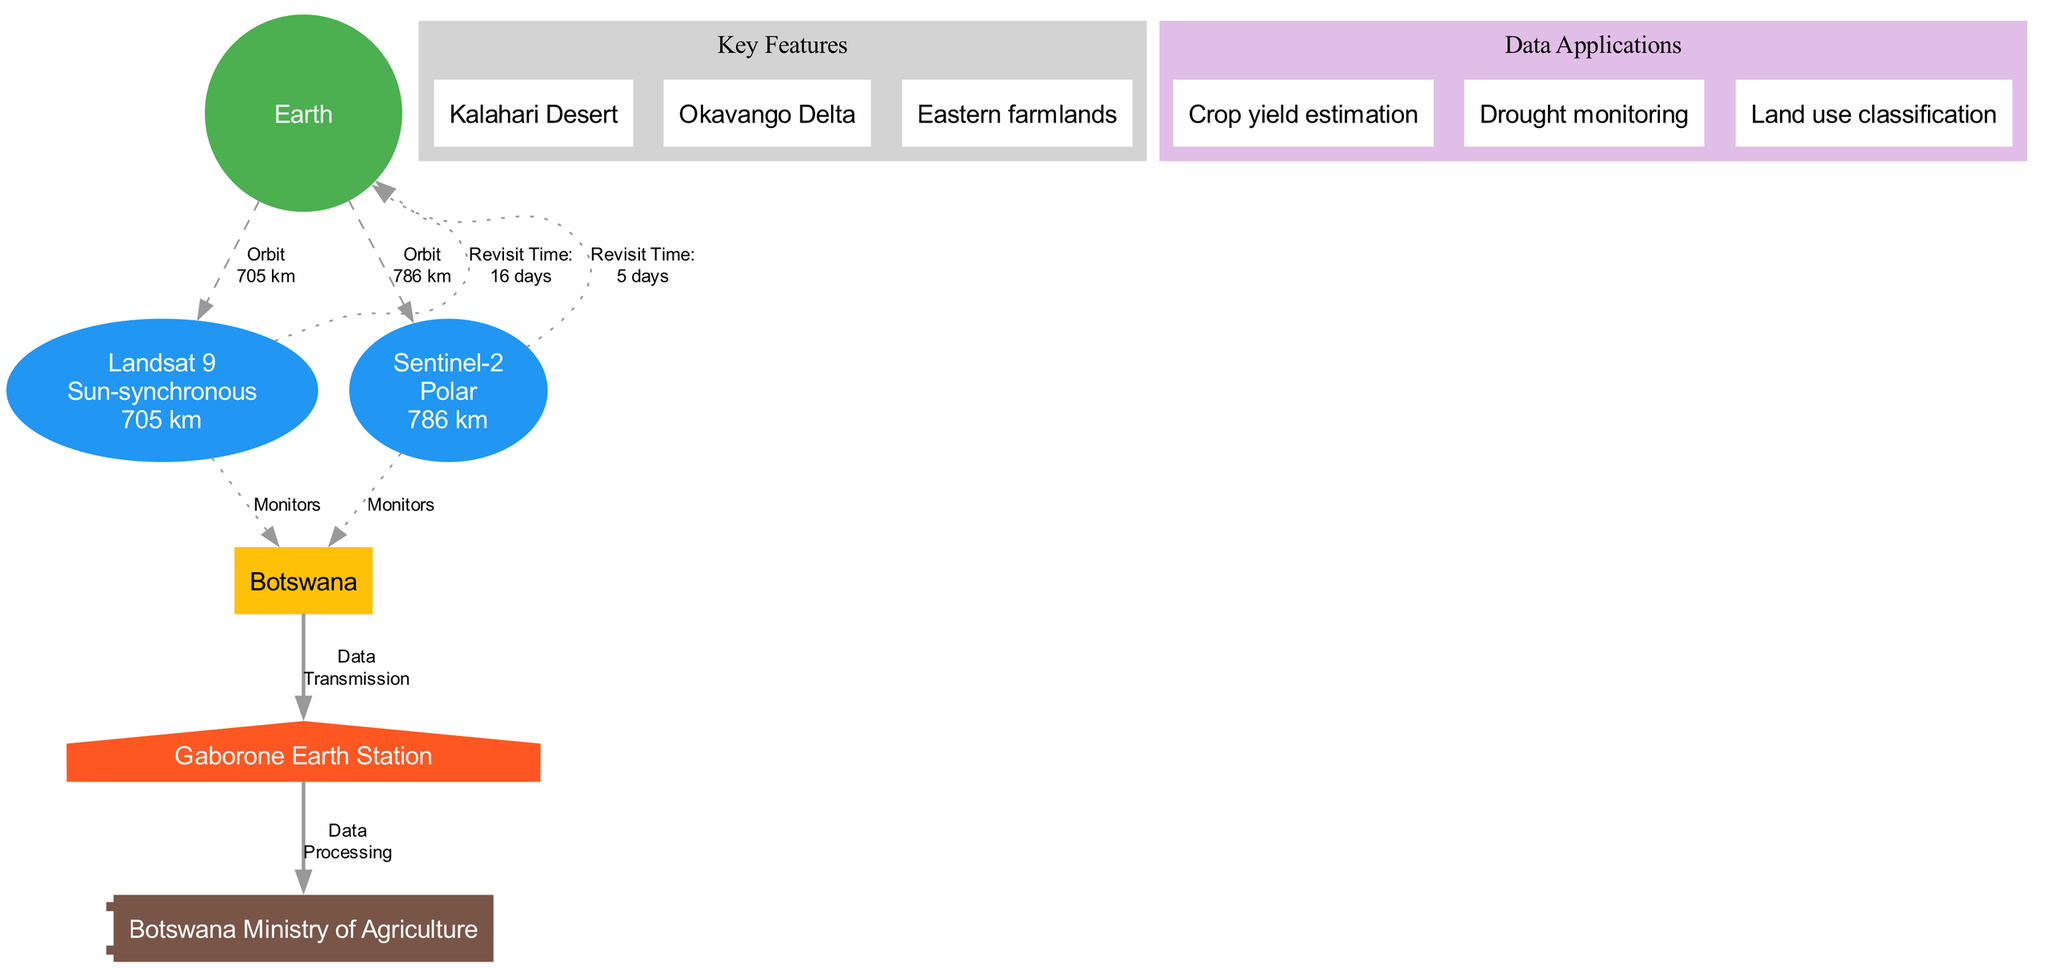What is the altitude of Landsat 9? The altitude for Landsat 9 is explicitly mentioned in the diagram, indicating it is 705 km above the Earth.
Answer: 705 km What is the revisit time for Sentinel-2? The revisit time for Sentinel-2 is shown in the diagram and is given as 5 days, meaning it passes over the same point on Earth every 5 days.
Answer: 5 days Which key feature is located in Botswana? The diagram lists three key features for Botswana, including the Kalahari Desert, Okavango Delta, and Eastern farmlands. One of these is the Kalahari Desert, identified as a significant geographical feature in Botswana.
Answer: Kalahari Desert How many satellites are used for agricultural monitoring in the diagram? The diagram specifically shows two satellites, Landsat 9 and Sentinel-2, which are dedicated to agricultural monitoring over Botswana.
Answer: 2 What is the data application related to drought? Among the listed data applications in the diagram, one directly relates to drought monitoring, indicating how satellite data is utilized in tracking drought conditions in Botswana.
Answer: Drought monitoring What type of orbit does Landsat 9 have? The orbit type for Landsat 9 is labeled in the diagram as sun-synchronous, which means the satellite maintains a constant position relative to the sun, crucial for consistent imaging conditions.
Answer: Sun-synchronous What is the relationship between the coverage area and the ground station? The diagram depicts the ground station in Gaborone as connected to the coverage area of Botswana through a bold edge labeled 'Data Transmission,' indicating that data from the satellites is sent to this ground station for processing.
Answer: Data Transmission What is the color of the Earth node in the diagram? In the diagram, the Earth node is vividly colored green (#4CAF50), which is explicitly specified to visually differentiate it as the central body of the diagram.
Answer: Green What type of orbit does Sentinel-2 have? The orbit type for Sentinel-2, as indicated in the diagram, is polar, which means it follows a path that takes it over the poles, allowing it to cover a broad swath of the Earth's surface including Botswana.
Answer: Polar 